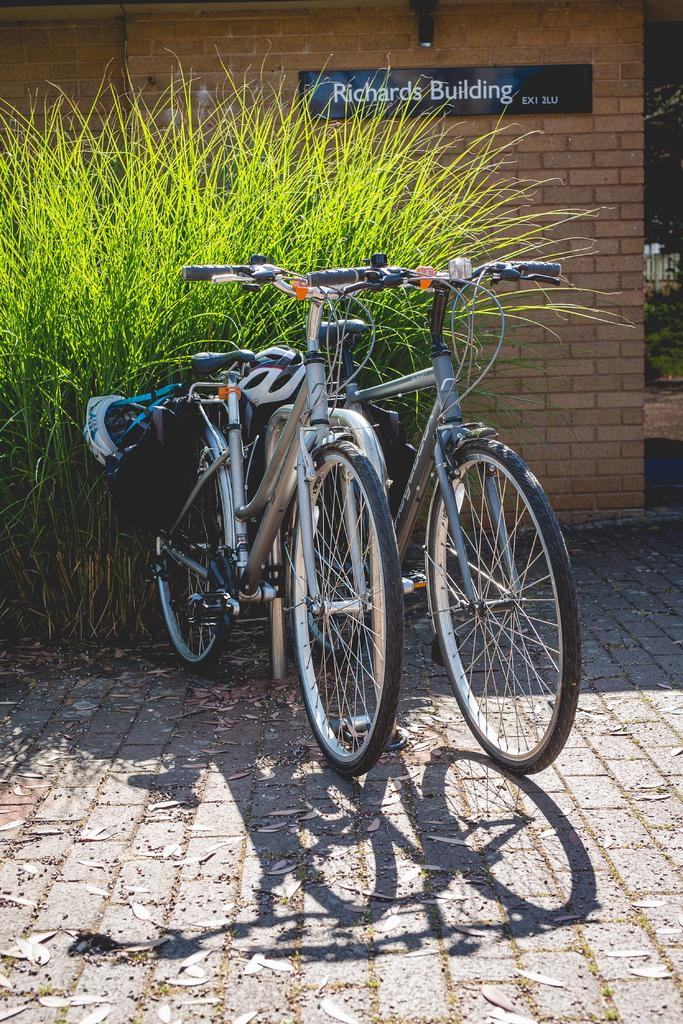How many cycles are visible in the image? There are two cycles in the image. What is the location of the cycles in relation to other objects? The cycles are in front of plants. What can be seen in the background of the image? There is a wall in the background of the image. Is there any text or information displayed on the wall? Yes, there is a name board on the wall. Can you see any eggs being used as decoration on the cycles in the image? There are no eggs present in the image, and they are not being used as decoration on the cycles. Is there a seashore visible in the background of the image? No, there is no seashore visible in the image; the background features a wall with a name board. 